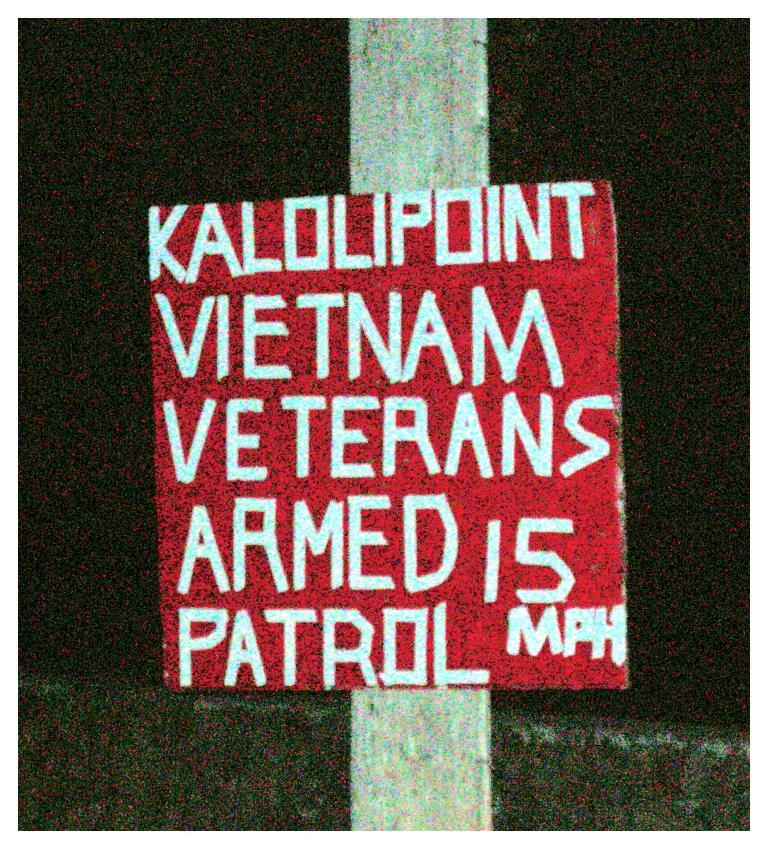What is attached to the pole in the image? There is a board attached to a pole in the image. What can be seen on the board? There is text on the board. What is located at the bottom of the image? There is a wall at the bottom of the image. What color is the background of the image? The background of the image is black. Can you tell me how many copies of the text are present on the island in the image? There is no island or copies of the text present in the image; it only features a board with text attached to a pole and a black background. 